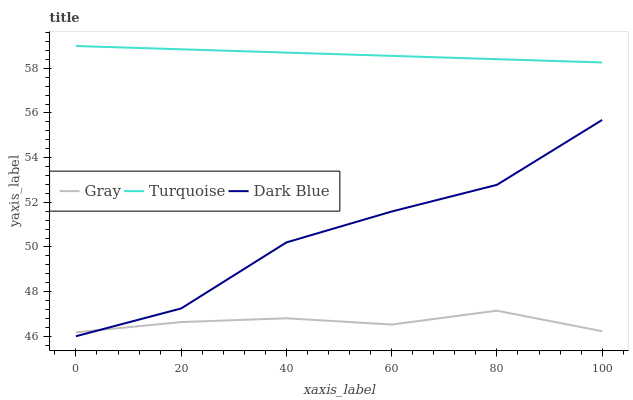Does Dark Blue have the minimum area under the curve?
Answer yes or no. No. Does Dark Blue have the maximum area under the curve?
Answer yes or no. No. Is Dark Blue the smoothest?
Answer yes or no. No. Is Turquoise the roughest?
Answer yes or no. No. Does Turquoise have the lowest value?
Answer yes or no. No. Does Dark Blue have the highest value?
Answer yes or no. No. Is Dark Blue less than Turquoise?
Answer yes or no. Yes. Is Turquoise greater than Dark Blue?
Answer yes or no. Yes. Does Dark Blue intersect Turquoise?
Answer yes or no. No. 